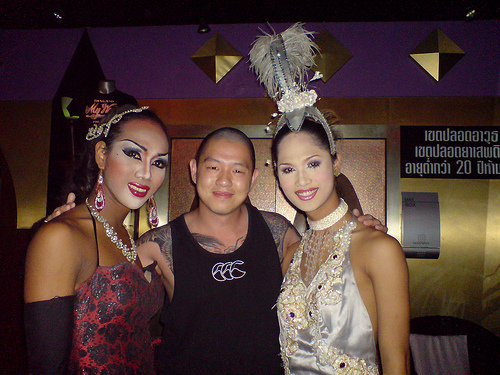<image>
Can you confirm if the woman is to the left of the man? Yes. From this viewpoint, the woman is positioned to the left side relative to the man. 